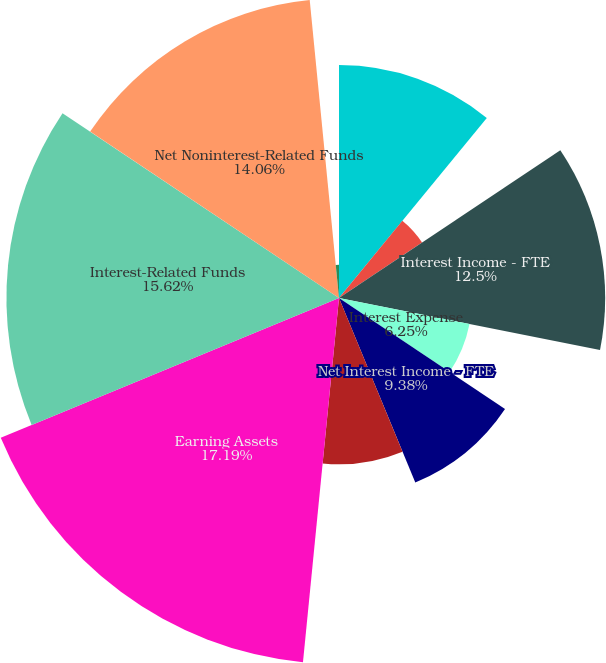Convert chart. <chart><loc_0><loc_0><loc_500><loc_500><pie_chart><fcel>Interest Income - GAAP<fcel>FTE Adjustment<fcel>Interest Income - FTE<fcel>Interest Expense<fcel>Net Interest Income - FTE<fcel>Net Interest Income - GAAP<fcel>Earning Assets<fcel>Interest-Related Funds<fcel>Net Noninterest-Related Funds<fcel>Interest Rate Spread<nl><fcel>10.94%<fcel>4.69%<fcel>12.5%<fcel>6.25%<fcel>9.38%<fcel>7.81%<fcel>17.19%<fcel>15.62%<fcel>14.06%<fcel>1.56%<nl></chart> 